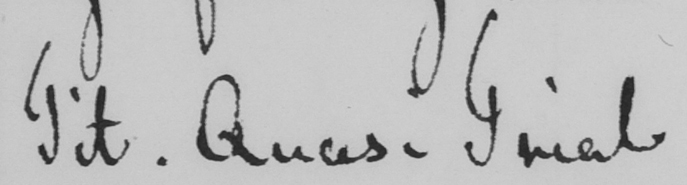Can you tell me what this handwritten text says? Tit  . Quasi Trial 